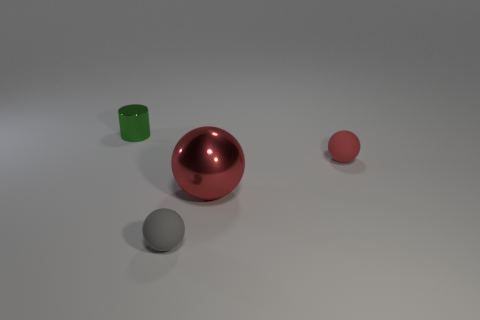There is a tiny cylinder that is behind the metal thing on the right side of the small cylinder that is on the left side of the tiny gray rubber thing; what is it made of?
Ensure brevity in your answer.  Metal. Is there a green cylinder of the same size as the red matte object?
Offer a very short reply. Yes. There is a red ball that is the same material as the green object; what is its size?
Offer a terse response. Large. What is the shape of the green thing?
Make the answer very short. Cylinder. Are the green thing and the red object that is to the left of the red matte thing made of the same material?
Your response must be concise. Yes. How many objects are either green metal cylinders or tiny gray spheres?
Ensure brevity in your answer.  2. Are there any small green objects?
Provide a succinct answer. Yes. There is a matte object right of the shiny object on the right side of the tiny shiny cylinder; what is its shape?
Offer a terse response. Sphere. What number of objects are small red matte balls on the right side of the big red object or rubber spheres to the right of the green cylinder?
Offer a very short reply. 2. There is another sphere that is the same size as the red matte ball; what material is it?
Your answer should be very brief. Rubber. 